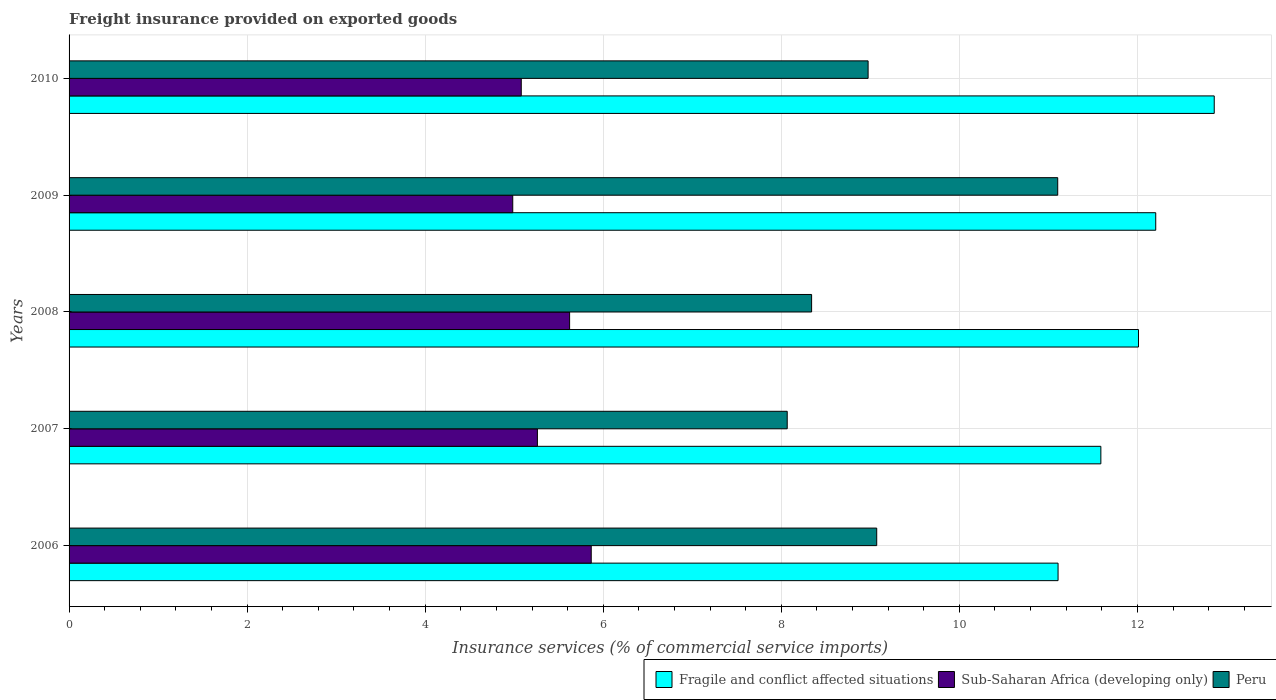How many different coloured bars are there?
Ensure brevity in your answer.  3. How many groups of bars are there?
Ensure brevity in your answer.  5. Are the number of bars per tick equal to the number of legend labels?
Provide a short and direct response. Yes. How many bars are there on the 2nd tick from the top?
Give a very brief answer. 3. What is the label of the 3rd group of bars from the top?
Ensure brevity in your answer.  2008. In how many cases, is the number of bars for a given year not equal to the number of legend labels?
Give a very brief answer. 0. What is the freight insurance provided on exported goods in Peru in 2009?
Provide a succinct answer. 11.1. Across all years, what is the maximum freight insurance provided on exported goods in Sub-Saharan Africa (developing only)?
Provide a succinct answer. 5.87. Across all years, what is the minimum freight insurance provided on exported goods in Fragile and conflict affected situations?
Provide a short and direct response. 11.11. In which year was the freight insurance provided on exported goods in Sub-Saharan Africa (developing only) maximum?
Give a very brief answer. 2006. In which year was the freight insurance provided on exported goods in Fragile and conflict affected situations minimum?
Ensure brevity in your answer.  2006. What is the total freight insurance provided on exported goods in Fragile and conflict affected situations in the graph?
Provide a short and direct response. 59.78. What is the difference between the freight insurance provided on exported goods in Fragile and conflict affected situations in 2009 and that in 2010?
Provide a short and direct response. -0.66. What is the difference between the freight insurance provided on exported goods in Fragile and conflict affected situations in 2010 and the freight insurance provided on exported goods in Peru in 2009?
Provide a short and direct response. 1.76. What is the average freight insurance provided on exported goods in Fragile and conflict affected situations per year?
Your response must be concise. 11.96. In the year 2009, what is the difference between the freight insurance provided on exported goods in Peru and freight insurance provided on exported goods in Fragile and conflict affected situations?
Offer a very short reply. -1.1. What is the ratio of the freight insurance provided on exported goods in Sub-Saharan Africa (developing only) in 2006 to that in 2010?
Your answer should be compact. 1.15. Is the freight insurance provided on exported goods in Sub-Saharan Africa (developing only) in 2006 less than that in 2010?
Make the answer very short. No. What is the difference between the highest and the second highest freight insurance provided on exported goods in Fragile and conflict affected situations?
Offer a terse response. 0.66. What is the difference between the highest and the lowest freight insurance provided on exported goods in Sub-Saharan Africa (developing only)?
Offer a terse response. 0.88. What does the 1st bar from the top in 2010 represents?
Your response must be concise. Peru. What does the 1st bar from the bottom in 2007 represents?
Ensure brevity in your answer.  Fragile and conflict affected situations. Is it the case that in every year, the sum of the freight insurance provided on exported goods in Peru and freight insurance provided on exported goods in Sub-Saharan Africa (developing only) is greater than the freight insurance provided on exported goods in Fragile and conflict affected situations?
Your answer should be very brief. Yes. How many bars are there?
Provide a short and direct response. 15. How many years are there in the graph?
Give a very brief answer. 5. Does the graph contain any zero values?
Your response must be concise. No. Does the graph contain grids?
Offer a very short reply. Yes. How many legend labels are there?
Offer a very short reply. 3. How are the legend labels stacked?
Your answer should be compact. Horizontal. What is the title of the graph?
Offer a very short reply. Freight insurance provided on exported goods. Does "Guinea" appear as one of the legend labels in the graph?
Give a very brief answer. No. What is the label or title of the X-axis?
Give a very brief answer. Insurance services (% of commercial service imports). What is the Insurance services (% of commercial service imports) of Fragile and conflict affected situations in 2006?
Your answer should be compact. 11.11. What is the Insurance services (% of commercial service imports) in Sub-Saharan Africa (developing only) in 2006?
Provide a succinct answer. 5.87. What is the Insurance services (% of commercial service imports) in Peru in 2006?
Your answer should be very brief. 9.07. What is the Insurance services (% of commercial service imports) of Fragile and conflict affected situations in 2007?
Give a very brief answer. 11.59. What is the Insurance services (% of commercial service imports) of Sub-Saharan Africa (developing only) in 2007?
Offer a very short reply. 5.26. What is the Insurance services (% of commercial service imports) in Peru in 2007?
Offer a terse response. 8.07. What is the Insurance services (% of commercial service imports) in Fragile and conflict affected situations in 2008?
Ensure brevity in your answer.  12.01. What is the Insurance services (% of commercial service imports) in Sub-Saharan Africa (developing only) in 2008?
Your answer should be very brief. 5.62. What is the Insurance services (% of commercial service imports) of Peru in 2008?
Provide a succinct answer. 8.34. What is the Insurance services (% of commercial service imports) in Fragile and conflict affected situations in 2009?
Your response must be concise. 12.21. What is the Insurance services (% of commercial service imports) in Sub-Saharan Africa (developing only) in 2009?
Provide a short and direct response. 4.98. What is the Insurance services (% of commercial service imports) in Peru in 2009?
Provide a short and direct response. 11.1. What is the Insurance services (% of commercial service imports) of Fragile and conflict affected situations in 2010?
Keep it short and to the point. 12.86. What is the Insurance services (% of commercial service imports) of Sub-Saharan Africa (developing only) in 2010?
Offer a very short reply. 5.08. What is the Insurance services (% of commercial service imports) of Peru in 2010?
Offer a very short reply. 8.98. Across all years, what is the maximum Insurance services (% of commercial service imports) in Fragile and conflict affected situations?
Provide a succinct answer. 12.86. Across all years, what is the maximum Insurance services (% of commercial service imports) in Sub-Saharan Africa (developing only)?
Your answer should be compact. 5.87. Across all years, what is the maximum Insurance services (% of commercial service imports) in Peru?
Keep it short and to the point. 11.1. Across all years, what is the minimum Insurance services (% of commercial service imports) of Fragile and conflict affected situations?
Make the answer very short. 11.11. Across all years, what is the minimum Insurance services (% of commercial service imports) in Sub-Saharan Africa (developing only)?
Make the answer very short. 4.98. Across all years, what is the minimum Insurance services (% of commercial service imports) of Peru?
Ensure brevity in your answer.  8.07. What is the total Insurance services (% of commercial service imports) of Fragile and conflict affected situations in the graph?
Make the answer very short. 59.78. What is the total Insurance services (% of commercial service imports) of Sub-Saharan Africa (developing only) in the graph?
Provide a succinct answer. 26.81. What is the total Insurance services (% of commercial service imports) of Peru in the graph?
Offer a very short reply. 45.56. What is the difference between the Insurance services (% of commercial service imports) of Fragile and conflict affected situations in 2006 and that in 2007?
Offer a very short reply. -0.48. What is the difference between the Insurance services (% of commercial service imports) of Sub-Saharan Africa (developing only) in 2006 and that in 2007?
Provide a short and direct response. 0.6. What is the difference between the Insurance services (% of commercial service imports) in Peru in 2006 and that in 2007?
Give a very brief answer. 1.01. What is the difference between the Insurance services (% of commercial service imports) in Fragile and conflict affected situations in 2006 and that in 2008?
Your answer should be very brief. -0.9. What is the difference between the Insurance services (% of commercial service imports) of Sub-Saharan Africa (developing only) in 2006 and that in 2008?
Keep it short and to the point. 0.24. What is the difference between the Insurance services (% of commercial service imports) in Peru in 2006 and that in 2008?
Make the answer very short. 0.73. What is the difference between the Insurance services (% of commercial service imports) in Fragile and conflict affected situations in 2006 and that in 2009?
Keep it short and to the point. -1.1. What is the difference between the Insurance services (% of commercial service imports) in Sub-Saharan Africa (developing only) in 2006 and that in 2009?
Provide a succinct answer. 0.88. What is the difference between the Insurance services (% of commercial service imports) in Peru in 2006 and that in 2009?
Give a very brief answer. -2.03. What is the difference between the Insurance services (% of commercial service imports) in Fragile and conflict affected situations in 2006 and that in 2010?
Keep it short and to the point. -1.75. What is the difference between the Insurance services (% of commercial service imports) of Sub-Saharan Africa (developing only) in 2006 and that in 2010?
Your answer should be compact. 0.79. What is the difference between the Insurance services (% of commercial service imports) of Peru in 2006 and that in 2010?
Provide a succinct answer. 0.1. What is the difference between the Insurance services (% of commercial service imports) of Fragile and conflict affected situations in 2007 and that in 2008?
Give a very brief answer. -0.42. What is the difference between the Insurance services (% of commercial service imports) of Sub-Saharan Africa (developing only) in 2007 and that in 2008?
Your response must be concise. -0.36. What is the difference between the Insurance services (% of commercial service imports) in Peru in 2007 and that in 2008?
Offer a terse response. -0.27. What is the difference between the Insurance services (% of commercial service imports) of Fragile and conflict affected situations in 2007 and that in 2009?
Keep it short and to the point. -0.62. What is the difference between the Insurance services (% of commercial service imports) of Sub-Saharan Africa (developing only) in 2007 and that in 2009?
Your response must be concise. 0.28. What is the difference between the Insurance services (% of commercial service imports) of Peru in 2007 and that in 2009?
Your answer should be very brief. -3.04. What is the difference between the Insurance services (% of commercial service imports) of Fragile and conflict affected situations in 2007 and that in 2010?
Make the answer very short. -1.27. What is the difference between the Insurance services (% of commercial service imports) of Sub-Saharan Africa (developing only) in 2007 and that in 2010?
Keep it short and to the point. 0.18. What is the difference between the Insurance services (% of commercial service imports) in Peru in 2007 and that in 2010?
Your answer should be very brief. -0.91. What is the difference between the Insurance services (% of commercial service imports) in Fragile and conflict affected situations in 2008 and that in 2009?
Provide a succinct answer. -0.19. What is the difference between the Insurance services (% of commercial service imports) of Sub-Saharan Africa (developing only) in 2008 and that in 2009?
Give a very brief answer. 0.64. What is the difference between the Insurance services (% of commercial service imports) in Peru in 2008 and that in 2009?
Provide a succinct answer. -2.76. What is the difference between the Insurance services (% of commercial service imports) in Fragile and conflict affected situations in 2008 and that in 2010?
Give a very brief answer. -0.85. What is the difference between the Insurance services (% of commercial service imports) of Sub-Saharan Africa (developing only) in 2008 and that in 2010?
Provide a short and direct response. 0.54. What is the difference between the Insurance services (% of commercial service imports) in Peru in 2008 and that in 2010?
Your answer should be very brief. -0.63. What is the difference between the Insurance services (% of commercial service imports) in Fragile and conflict affected situations in 2009 and that in 2010?
Offer a terse response. -0.66. What is the difference between the Insurance services (% of commercial service imports) in Sub-Saharan Africa (developing only) in 2009 and that in 2010?
Provide a short and direct response. -0.1. What is the difference between the Insurance services (% of commercial service imports) of Peru in 2009 and that in 2010?
Make the answer very short. 2.13. What is the difference between the Insurance services (% of commercial service imports) in Fragile and conflict affected situations in 2006 and the Insurance services (% of commercial service imports) in Sub-Saharan Africa (developing only) in 2007?
Give a very brief answer. 5.85. What is the difference between the Insurance services (% of commercial service imports) of Fragile and conflict affected situations in 2006 and the Insurance services (% of commercial service imports) of Peru in 2007?
Your answer should be compact. 3.04. What is the difference between the Insurance services (% of commercial service imports) of Sub-Saharan Africa (developing only) in 2006 and the Insurance services (% of commercial service imports) of Peru in 2007?
Provide a short and direct response. -2.2. What is the difference between the Insurance services (% of commercial service imports) in Fragile and conflict affected situations in 2006 and the Insurance services (% of commercial service imports) in Sub-Saharan Africa (developing only) in 2008?
Offer a very short reply. 5.49. What is the difference between the Insurance services (% of commercial service imports) of Fragile and conflict affected situations in 2006 and the Insurance services (% of commercial service imports) of Peru in 2008?
Ensure brevity in your answer.  2.77. What is the difference between the Insurance services (% of commercial service imports) of Sub-Saharan Africa (developing only) in 2006 and the Insurance services (% of commercial service imports) of Peru in 2008?
Ensure brevity in your answer.  -2.48. What is the difference between the Insurance services (% of commercial service imports) in Fragile and conflict affected situations in 2006 and the Insurance services (% of commercial service imports) in Sub-Saharan Africa (developing only) in 2009?
Offer a very short reply. 6.13. What is the difference between the Insurance services (% of commercial service imports) in Fragile and conflict affected situations in 2006 and the Insurance services (% of commercial service imports) in Peru in 2009?
Ensure brevity in your answer.  0. What is the difference between the Insurance services (% of commercial service imports) of Sub-Saharan Africa (developing only) in 2006 and the Insurance services (% of commercial service imports) of Peru in 2009?
Your response must be concise. -5.24. What is the difference between the Insurance services (% of commercial service imports) in Fragile and conflict affected situations in 2006 and the Insurance services (% of commercial service imports) in Sub-Saharan Africa (developing only) in 2010?
Provide a short and direct response. 6.03. What is the difference between the Insurance services (% of commercial service imports) in Fragile and conflict affected situations in 2006 and the Insurance services (% of commercial service imports) in Peru in 2010?
Your answer should be compact. 2.13. What is the difference between the Insurance services (% of commercial service imports) in Sub-Saharan Africa (developing only) in 2006 and the Insurance services (% of commercial service imports) in Peru in 2010?
Your answer should be very brief. -3.11. What is the difference between the Insurance services (% of commercial service imports) of Fragile and conflict affected situations in 2007 and the Insurance services (% of commercial service imports) of Sub-Saharan Africa (developing only) in 2008?
Provide a short and direct response. 5.97. What is the difference between the Insurance services (% of commercial service imports) in Fragile and conflict affected situations in 2007 and the Insurance services (% of commercial service imports) in Peru in 2008?
Ensure brevity in your answer.  3.25. What is the difference between the Insurance services (% of commercial service imports) of Sub-Saharan Africa (developing only) in 2007 and the Insurance services (% of commercial service imports) of Peru in 2008?
Make the answer very short. -3.08. What is the difference between the Insurance services (% of commercial service imports) in Fragile and conflict affected situations in 2007 and the Insurance services (% of commercial service imports) in Sub-Saharan Africa (developing only) in 2009?
Offer a very short reply. 6.61. What is the difference between the Insurance services (% of commercial service imports) in Fragile and conflict affected situations in 2007 and the Insurance services (% of commercial service imports) in Peru in 2009?
Provide a succinct answer. 0.48. What is the difference between the Insurance services (% of commercial service imports) in Sub-Saharan Africa (developing only) in 2007 and the Insurance services (% of commercial service imports) in Peru in 2009?
Offer a very short reply. -5.84. What is the difference between the Insurance services (% of commercial service imports) of Fragile and conflict affected situations in 2007 and the Insurance services (% of commercial service imports) of Sub-Saharan Africa (developing only) in 2010?
Ensure brevity in your answer.  6.51. What is the difference between the Insurance services (% of commercial service imports) in Fragile and conflict affected situations in 2007 and the Insurance services (% of commercial service imports) in Peru in 2010?
Ensure brevity in your answer.  2.61. What is the difference between the Insurance services (% of commercial service imports) of Sub-Saharan Africa (developing only) in 2007 and the Insurance services (% of commercial service imports) of Peru in 2010?
Provide a short and direct response. -3.71. What is the difference between the Insurance services (% of commercial service imports) of Fragile and conflict affected situations in 2008 and the Insurance services (% of commercial service imports) of Sub-Saharan Africa (developing only) in 2009?
Ensure brevity in your answer.  7.03. What is the difference between the Insurance services (% of commercial service imports) in Fragile and conflict affected situations in 2008 and the Insurance services (% of commercial service imports) in Peru in 2009?
Offer a terse response. 0.91. What is the difference between the Insurance services (% of commercial service imports) of Sub-Saharan Africa (developing only) in 2008 and the Insurance services (% of commercial service imports) of Peru in 2009?
Keep it short and to the point. -5.48. What is the difference between the Insurance services (% of commercial service imports) in Fragile and conflict affected situations in 2008 and the Insurance services (% of commercial service imports) in Sub-Saharan Africa (developing only) in 2010?
Make the answer very short. 6.93. What is the difference between the Insurance services (% of commercial service imports) in Fragile and conflict affected situations in 2008 and the Insurance services (% of commercial service imports) in Peru in 2010?
Offer a terse response. 3.04. What is the difference between the Insurance services (% of commercial service imports) of Sub-Saharan Africa (developing only) in 2008 and the Insurance services (% of commercial service imports) of Peru in 2010?
Ensure brevity in your answer.  -3.35. What is the difference between the Insurance services (% of commercial service imports) of Fragile and conflict affected situations in 2009 and the Insurance services (% of commercial service imports) of Sub-Saharan Africa (developing only) in 2010?
Provide a succinct answer. 7.13. What is the difference between the Insurance services (% of commercial service imports) of Fragile and conflict affected situations in 2009 and the Insurance services (% of commercial service imports) of Peru in 2010?
Your answer should be very brief. 3.23. What is the difference between the Insurance services (% of commercial service imports) in Sub-Saharan Africa (developing only) in 2009 and the Insurance services (% of commercial service imports) in Peru in 2010?
Offer a very short reply. -3.99. What is the average Insurance services (% of commercial service imports) in Fragile and conflict affected situations per year?
Offer a very short reply. 11.96. What is the average Insurance services (% of commercial service imports) in Sub-Saharan Africa (developing only) per year?
Offer a terse response. 5.36. What is the average Insurance services (% of commercial service imports) of Peru per year?
Give a very brief answer. 9.11. In the year 2006, what is the difference between the Insurance services (% of commercial service imports) of Fragile and conflict affected situations and Insurance services (% of commercial service imports) of Sub-Saharan Africa (developing only)?
Provide a succinct answer. 5.24. In the year 2006, what is the difference between the Insurance services (% of commercial service imports) in Fragile and conflict affected situations and Insurance services (% of commercial service imports) in Peru?
Provide a succinct answer. 2.04. In the year 2006, what is the difference between the Insurance services (% of commercial service imports) in Sub-Saharan Africa (developing only) and Insurance services (% of commercial service imports) in Peru?
Provide a succinct answer. -3.21. In the year 2007, what is the difference between the Insurance services (% of commercial service imports) in Fragile and conflict affected situations and Insurance services (% of commercial service imports) in Sub-Saharan Africa (developing only)?
Make the answer very short. 6.33. In the year 2007, what is the difference between the Insurance services (% of commercial service imports) of Fragile and conflict affected situations and Insurance services (% of commercial service imports) of Peru?
Keep it short and to the point. 3.52. In the year 2007, what is the difference between the Insurance services (% of commercial service imports) in Sub-Saharan Africa (developing only) and Insurance services (% of commercial service imports) in Peru?
Your answer should be compact. -2.81. In the year 2008, what is the difference between the Insurance services (% of commercial service imports) in Fragile and conflict affected situations and Insurance services (% of commercial service imports) in Sub-Saharan Africa (developing only)?
Your response must be concise. 6.39. In the year 2008, what is the difference between the Insurance services (% of commercial service imports) of Fragile and conflict affected situations and Insurance services (% of commercial service imports) of Peru?
Ensure brevity in your answer.  3.67. In the year 2008, what is the difference between the Insurance services (% of commercial service imports) of Sub-Saharan Africa (developing only) and Insurance services (% of commercial service imports) of Peru?
Offer a terse response. -2.72. In the year 2009, what is the difference between the Insurance services (% of commercial service imports) of Fragile and conflict affected situations and Insurance services (% of commercial service imports) of Sub-Saharan Africa (developing only)?
Give a very brief answer. 7.22. In the year 2009, what is the difference between the Insurance services (% of commercial service imports) of Fragile and conflict affected situations and Insurance services (% of commercial service imports) of Peru?
Your answer should be compact. 1.1. In the year 2009, what is the difference between the Insurance services (% of commercial service imports) of Sub-Saharan Africa (developing only) and Insurance services (% of commercial service imports) of Peru?
Provide a short and direct response. -6.12. In the year 2010, what is the difference between the Insurance services (% of commercial service imports) of Fragile and conflict affected situations and Insurance services (% of commercial service imports) of Sub-Saharan Africa (developing only)?
Give a very brief answer. 7.78. In the year 2010, what is the difference between the Insurance services (% of commercial service imports) in Fragile and conflict affected situations and Insurance services (% of commercial service imports) in Peru?
Your response must be concise. 3.89. In the year 2010, what is the difference between the Insurance services (% of commercial service imports) of Sub-Saharan Africa (developing only) and Insurance services (% of commercial service imports) of Peru?
Offer a terse response. -3.9. What is the ratio of the Insurance services (% of commercial service imports) of Fragile and conflict affected situations in 2006 to that in 2007?
Ensure brevity in your answer.  0.96. What is the ratio of the Insurance services (% of commercial service imports) of Sub-Saharan Africa (developing only) in 2006 to that in 2007?
Your response must be concise. 1.11. What is the ratio of the Insurance services (% of commercial service imports) in Peru in 2006 to that in 2007?
Offer a terse response. 1.12. What is the ratio of the Insurance services (% of commercial service imports) of Fragile and conflict affected situations in 2006 to that in 2008?
Offer a very short reply. 0.92. What is the ratio of the Insurance services (% of commercial service imports) of Sub-Saharan Africa (developing only) in 2006 to that in 2008?
Your answer should be very brief. 1.04. What is the ratio of the Insurance services (% of commercial service imports) in Peru in 2006 to that in 2008?
Your answer should be compact. 1.09. What is the ratio of the Insurance services (% of commercial service imports) of Fragile and conflict affected situations in 2006 to that in 2009?
Keep it short and to the point. 0.91. What is the ratio of the Insurance services (% of commercial service imports) of Sub-Saharan Africa (developing only) in 2006 to that in 2009?
Your response must be concise. 1.18. What is the ratio of the Insurance services (% of commercial service imports) in Peru in 2006 to that in 2009?
Give a very brief answer. 0.82. What is the ratio of the Insurance services (% of commercial service imports) of Fragile and conflict affected situations in 2006 to that in 2010?
Make the answer very short. 0.86. What is the ratio of the Insurance services (% of commercial service imports) in Sub-Saharan Africa (developing only) in 2006 to that in 2010?
Make the answer very short. 1.15. What is the ratio of the Insurance services (% of commercial service imports) in Peru in 2006 to that in 2010?
Offer a terse response. 1.01. What is the ratio of the Insurance services (% of commercial service imports) in Fragile and conflict affected situations in 2007 to that in 2008?
Provide a succinct answer. 0.96. What is the ratio of the Insurance services (% of commercial service imports) of Sub-Saharan Africa (developing only) in 2007 to that in 2008?
Provide a short and direct response. 0.94. What is the ratio of the Insurance services (% of commercial service imports) of Peru in 2007 to that in 2008?
Your answer should be compact. 0.97. What is the ratio of the Insurance services (% of commercial service imports) in Fragile and conflict affected situations in 2007 to that in 2009?
Offer a very short reply. 0.95. What is the ratio of the Insurance services (% of commercial service imports) of Sub-Saharan Africa (developing only) in 2007 to that in 2009?
Offer a very short reply. 1.06. What is the ratio of the Insurance services (% of commercial service imports) of Peru in 2007 to that in 2009?
Your response must be concise. 0.73. What is the ratio of the Insurance services (% of commercial service imports) in Fragile and conflict affected situations in 2007 to that in 2010?
Keep it short and to the point. 0.9. What is the ratio of the Insurance services (% of commercial service imports) of Sub-Saharan Africa (developing only) in 2007 to that in 2010?
Provide a short and direct response. 1.04. What is the ratio of the Insurance services (% of commercial service imports) in Peru in 2007 to that in 2010?
Give a very brief answer. 0.9. What is the ratio of the Insurance services (% of commercial service imports) of Fragile and conflict affected situations in 2008 to that in 2009?
Ensure brevity in your answer.  0.98. What is the ratio of the Insurance services (% of commercial service imports) in Sub-Saharan Africa (developing only) in 2008 to that in 2009?
Provide a short and direct response. 1.13. What is the ratio of the Insurance services (% of commercial service imports) of Peru in 2008 to that in 2009?
Ensure brevity in your answer.  0.75. What is the ratio of the Insurance services (% of commercial service imports) of Fragile and conflict affected situations in 2008 to that in 2010?
Offer a very short reply. 0.93. What is the ratio of the Insurance services (% of commercial service imports) in Sub-Saharan Africa (developing only) in 2008 to that in 2010?
Your answer should be very brief. 1.11. What is the ratio of the Insurance services (% of commercial service imports) in Peru in 2008 to that in 2010?
Make the answer very short. 0.93. What is the ratio of the Insurance services (% of commercial service imports) in Fragile and conflict affected situations in 2009 to that in 2010?
Your answer should be compact. 0.95. What is the ratio of the Insurance services (% of commercial service imports) in Sub-Saharan Africa (developing only) in 2009 to that in 2010?
Your answer should be compact. 0.98. What is the ratio of the Insurance services (% of commercial service imports) in Peru in 2009 to that in 2010?
Ensure brevity in your answer.  1.24. What is the difference between the highest and the second highest Insurance services (% of commercial service imports) of Fragile and conflict affected situations?
Offer a very short reply. 0.66. What is the difference between the highest and the second highest Insurance services (% of commercial service imports) of Sub-Saharan Africa (developing only)?
Your answer should be very brief. 0.24. What is the difference between the highest and the second highest Insurance services (% of commercial service imports) of Peru?
Offer a terse response. 2.03. What is the difference between the highest and the lowest Insurance services (% of commercial service imports) of Fragile and conflict affected situations?
Your answer should be compact. 1.75. What is the difference between the highest and the lowest Insurance services (% of commercial service imports) in Sub-Saharan Africa (developing only)?
Your answer should be compact. 0.88. What is the difference between the highest and the lowest Insurance services (% of commercial service imports) in Peru?
Provide a succinct answer. 3.04. 